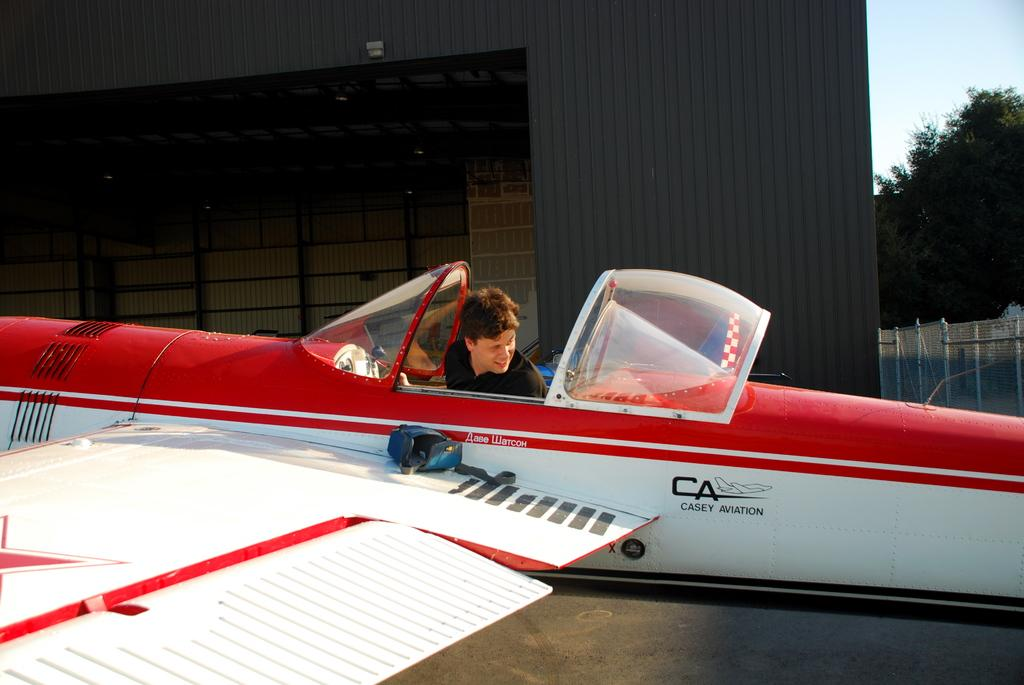<image>
Create a compact narrative representing the image presented. a plane belonging to casey aviation is parked 